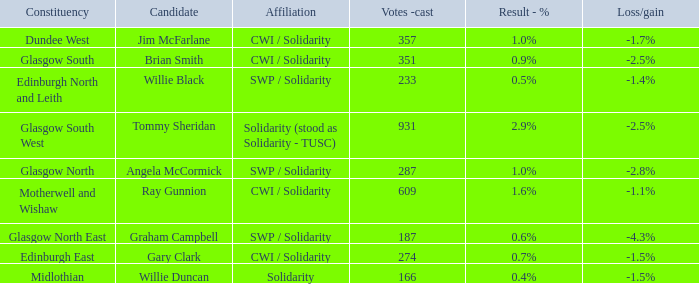Who was the nominee when the outcome - % was Tommy Sheridan. 